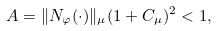<formula> <loc_0><loc_0><loc_500><loc_500>A = \| N _ { \varphi } ( \cdot ) \| _ { \mu } ( 1 + C _ { \mu } ) ^ { 2 } < 1 ,</formula> 